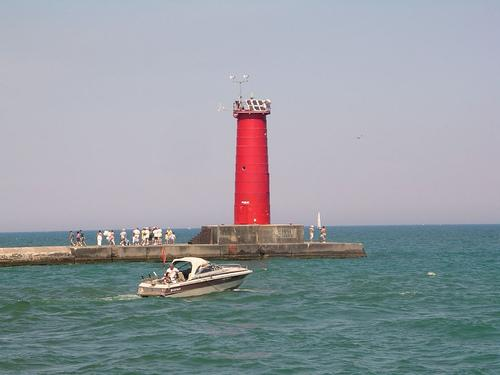How did the people standing near the lighthouse structure arrive here? Please explain your reasoning. walking. Only a boat could reach a place in the middle of the water. 